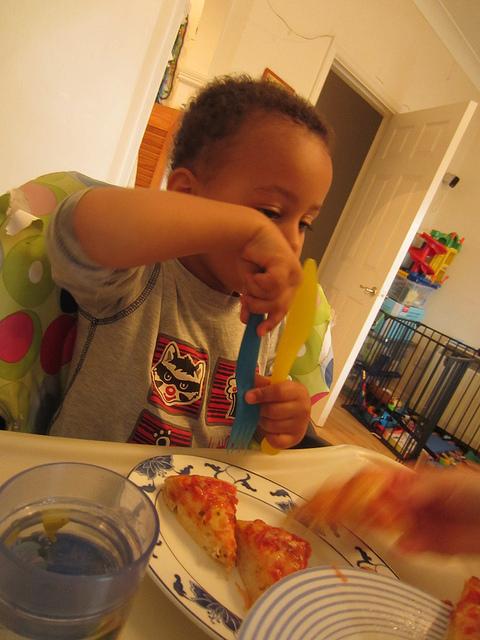Is the child shirt cotton?
Answer briefly. Yes. Is the door in the background open or closed?
Write a very short answer. Open. What is under the pizzas?
Give a very brief answer. Plate. What brand of water is on the table?
Quick response, please. Tap. Is the person dressed up?
Be succinct. No. How many children's arms are in view?
Quick response, please. 1. Where is the child's playpen?
Give a very brief answer. Behind door. What color is the boys hair?
Concise answer only. Brown. What is the boy holding?
Quick response, please. Utensils. Are they eating pizza?
Concise answer only. Yes. Is this meal being consumed in someone's home?
Answer briefly. Yes. What is on the child's shirt?
Give a very brief answer. Raccoon. Was his pizza made at home?
Answer briefly. Yes. Is there any meat in this meal?
Answer briefly. No. 